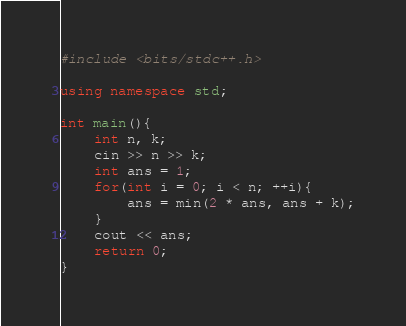Convert code to text. <code><loc_0><loc_0><loc_500><loc_500><_C++_>#include <bits/stdc++.h>

using namespace std;

int main(){
    int n, k;
    cin >> n >> k;
    int ans = 1;
    for(int i = 0; i < n; ++i){
        ans = min(2 * ans, ans + k);
    }
    cout << ans;
    return 0;
}
</code> 